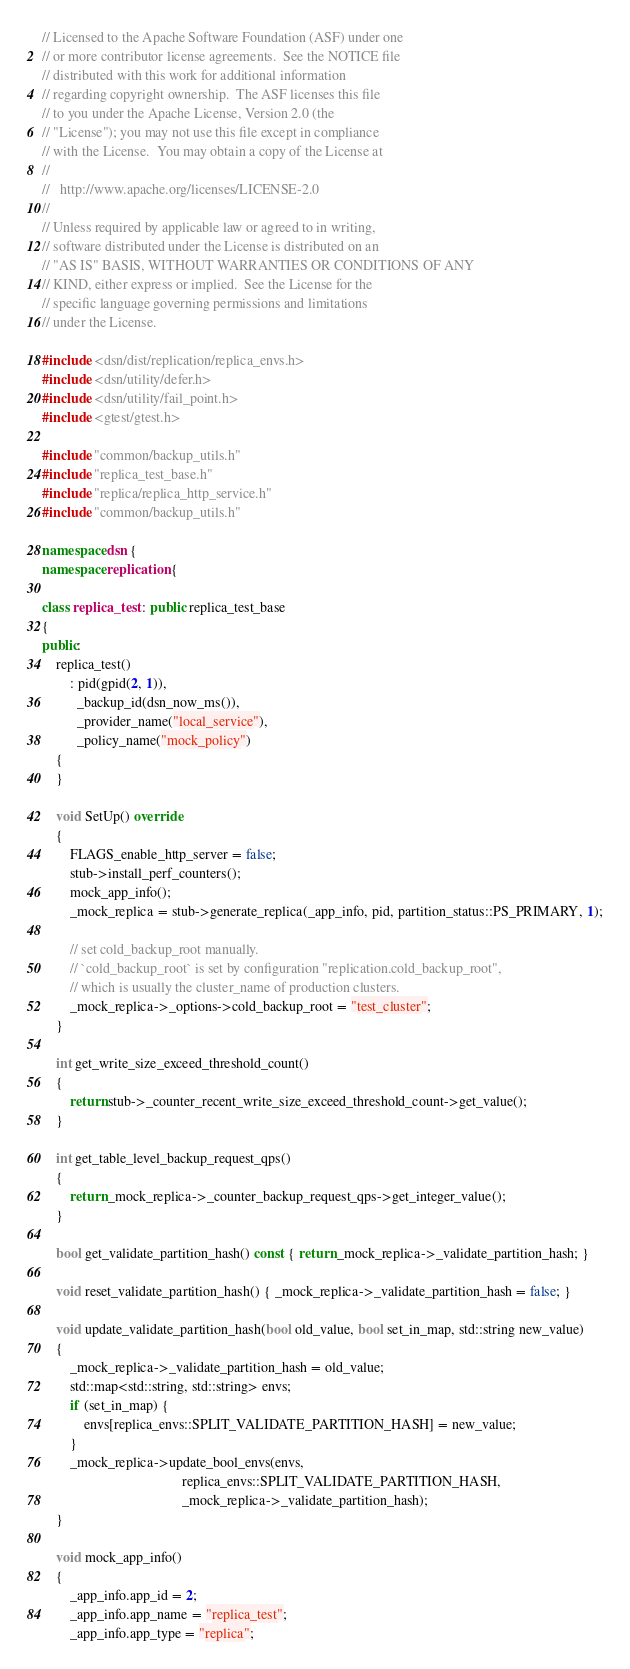Convert code to text. <code><loc_0><loc_0><loc_500><loc_500><_C++_>// Licensed to the Apache Software Foundation (ASF) under one
// or more contributor license agreements.  See the NOTICE file
// distributed with this work for additional information
// regarding copyright ownership.  The ASF licenses this file
// to you under the Apache License, Version 2.0 (the
// "License"); you may not use this file except in compliance
// with the License.  You may obtain a copy of the License at
//
//   http://www.apache.org/licenses/LICENSE-2.0
//
// Unless required by applicable law or agreed to in writing,
// software distributed under the License is distributed on an
// "AS IS" BASIS, WITHOUT WARRANTIES OR CONDITIONS OF ANY
// KIND, either express or implied.  See the License for the
// specific language governing permissions and limitations
// under the License.

#include <dsn/dist/replication/replica_envs.h>
#include <dsn/utility/defer.h>
#include <dsn/utility/fail_point.h>
#include <gtest/gtest.h>

#include "common/backup_utils.h"
#include "replica_test_base.h"
#include "replica/replica_http_service.h"
#include "common/backup_utils.h"

namespace dsn {
namespace replication {

class replica_test : public replica_test_base
{
public:
    replica_test()
        : pid(gpid(2, 1)),
          _backup_id(dsn_now_ms()),
          _provider_name("local_service"),
          _policy_name("mock_policy")
    {
    }

    void SetUp() override
    {
        FLAGS_enable_http_server = false;
        stub->install_perf_counters();
        mock_app_info();
        _mock_replica = stub->generate_replica(_app_info, pid, partition_status::PS_PRIMARY, 1);

        // set cold_backup_root manually.
        // `cold_backup_root` is set by configuration "replication.cold_backup_root",
        // which is usually the cluster_name of production clusters.
        _mock_replica->_options->cold_backup_root = "test_cluster";
    }

    int get_write_size_exceed_threshold_count()
    {
        return stub->_counter_recent_write_size_exceed_threshold_count->get_value();
    }

    int get_table_level_backup_request_qps()
    {
        return _mock_replica->_counter_backup_request_qps->get_integer_value();
    }

    bool get_validate_partition_hash() const { return _mock_replica->_validate_partition_hash; }

    void reset_validate_partition_hash() { _mock_replica->_validate_partition_hash = false; }

    void update_validate_partition_hash(bool old_value, bool set_in_map, std::string new_value)
    {
        _mock_replica->_validate_partition_hash = old_value;
        std::map<std::string, std::string> envs;
        if (set_in_map) {
            envs[replica_envs::SPLIT_VALIDATE_PARTITION_HASH] = new_value;
        }
        _mock_replica->update_bool_envs(envs,
                                        replica_envs::SPLIT_VALIDATE_PARTITION_HASH,
                                        _mock_replica->_validate_partition_hash);
    }

    void mock_app_info()
    {
        _app_info.app_id = 2;
        _app_info.app_name = "replica_test";
        _app_info.app_type = "replica";</code> 